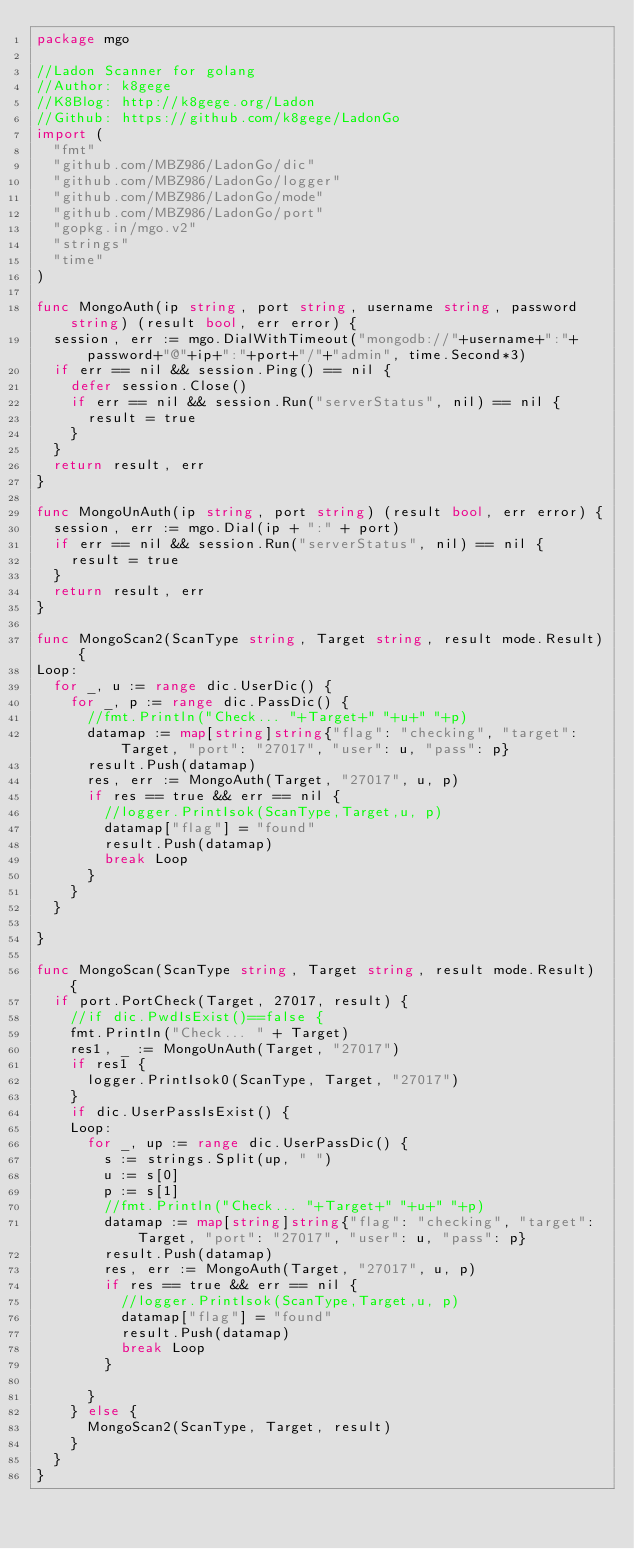Convert code to text. <code><loc_0><loc_0><loc_500><loc_500><_Go_>package mgo

//Ladon Scanner for golang
//Author: k8gege
//K8Blog: http://k8gege.org/Ladon
//Github: https://github.com/k8gege/LadonGo
import (
	"fmt"
	"github.com/MBZ986/LadonGo/dic"
	"github.com/MBZ986/LadonGo/logger"
	"github.com/MBZ986/LadonGo/mode"
	"github.com/MBZ986/LadonGo/port"
	"gopkg.in/mgo.v2"
	"strings"
	"time"
)

func MongoAuth(ip string, port string, username string, password string) (result bool, err error) {
	session, err := mgo.DialWithTimeout("mongodb://"+username+":"+password+"@"+ip+":"+port+"/"+"admin", time.Second*3)
	if err == nil && session.Ping() == nil {
		defer session.Close()
		if err == nil && session.Run("serverStatus", nil) == nil {
			result = true
		}
	}
	return result, err
}

func MongoUnAuth(ip string, port string) (result bool, err error) {
	session, err := mgo.Dial(ip + ":" + port)
	if err == nil && session.Run("serverStatus", nil) == nil {
		result = true
	}
	return result, err
}

func MongoScan2(ScanType string, Target string, result mode.Result) {
Loop:
	for _, u := range dic.UserDic() {
		for _, p := range dic.PassDic() {
			//fmt.Println("Check... "+Target+" "+u+" "+p)
			datamap := map[string]string{"flag": "checking", "target": Target, "port": "27017", "user": u, "pass": p}
			result.Push(datamap)
			res, err := MongoAuth(Target, "27017", u, p)
			if res == true && err == nil {
				//logger.PrintIsok(ScanType,Target,u, p)
				datamap["flag"] = "found"
				result.Push(datamap)
				break Loop
			}
		}
	}

}

func MongoScan(ScanType string, Target string, result mode.Result) {
	if port.PortCheck(Target, 27017, result) {
		//if dic.PwdIsExist()==false {
		fmt.Println("Check... " + Target)
		res1, _ := MongoUnAuth(Target, "27017")
		if res1 {
			logger.PrintIsok0(ScanType, Target, "27017")
		}
		if dic.UserPassIsExist() {
		Loop:
			for _, up := range dic.UserPassDic() {
				s := strings.Split(up, " ")
				u := s[0]
				p := s[1]
				//fmt.Println("Check... "+Target+" "+u+" "+p)
				datamap := map[string]string{"flag": "checking", "target": Target, "port": "27017", "user": u, "pass": p}
				result.Push(datamap)
				res, err := MongoAuth(Target, "27017", u, p)
				if res == true && err == nil {
					//logger.PrintIsok(ScanType,Target,u, p)
					datamap["flag"] = "found"
					result.Push(datamap)
					break Loop
				}

			}
		} else {
			MongoScan2(ScanType, Target, result)
		}
	}
}
</code> 